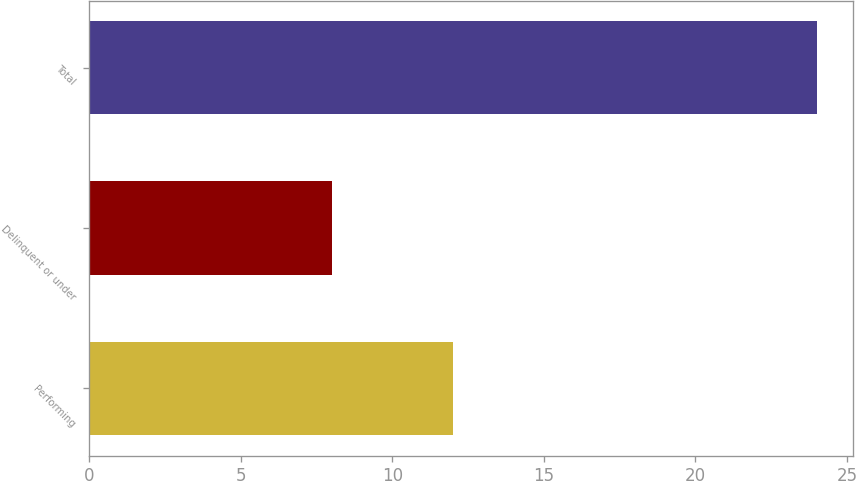Convert chart to OTSL. <chart><loc_0><loc_0><loc_500><loc_500><bar_chart><fcel>Performing<fcel>Delinquent or under<fcel>Total<nl><fcel>12<fcel>8<fcel>24<nl></chart> 